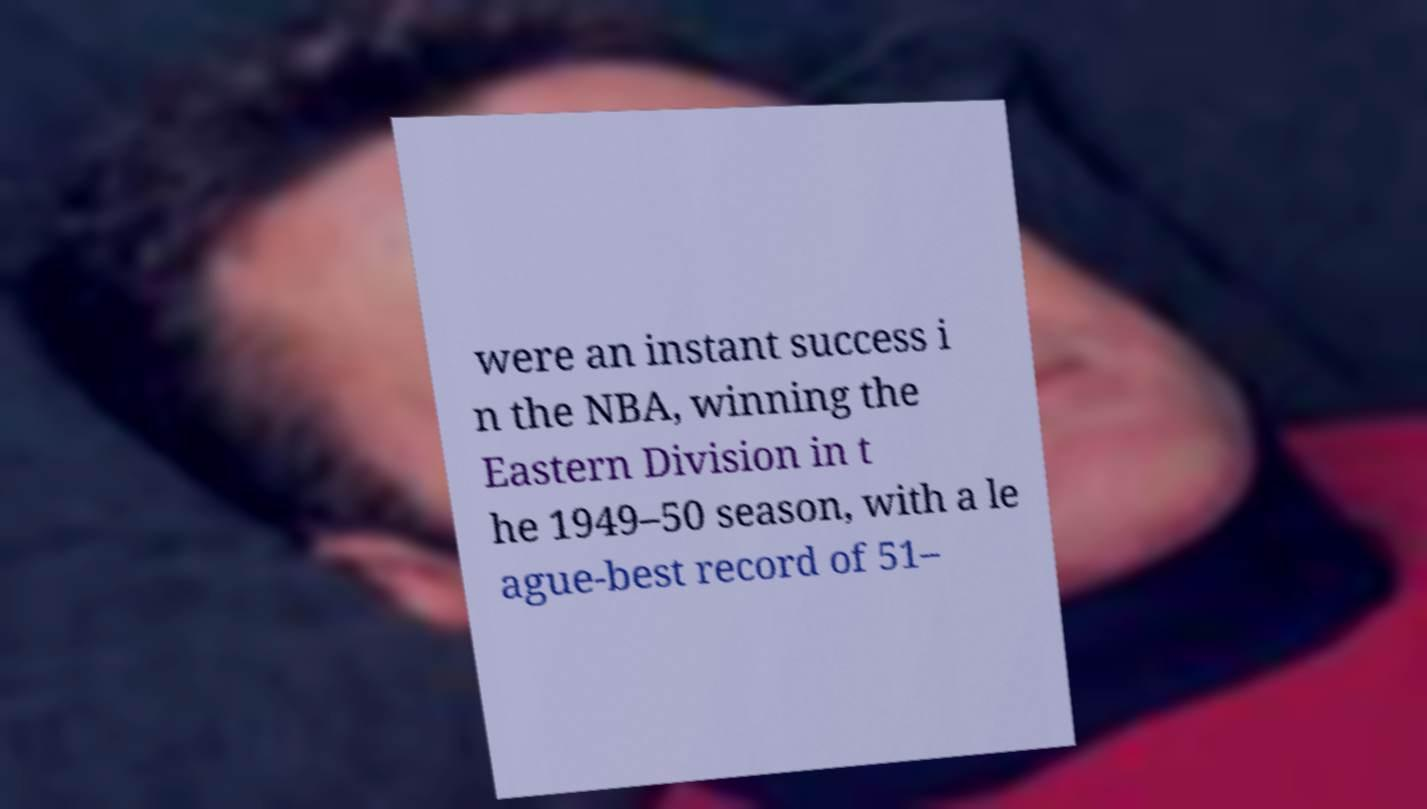For documentation purposes, I need the text within this image transcribed. Could you provide that? were an instant success i n the NBA, winning the Eastern Division in t he 1949–50 season, with a le ague-best record of 51– 